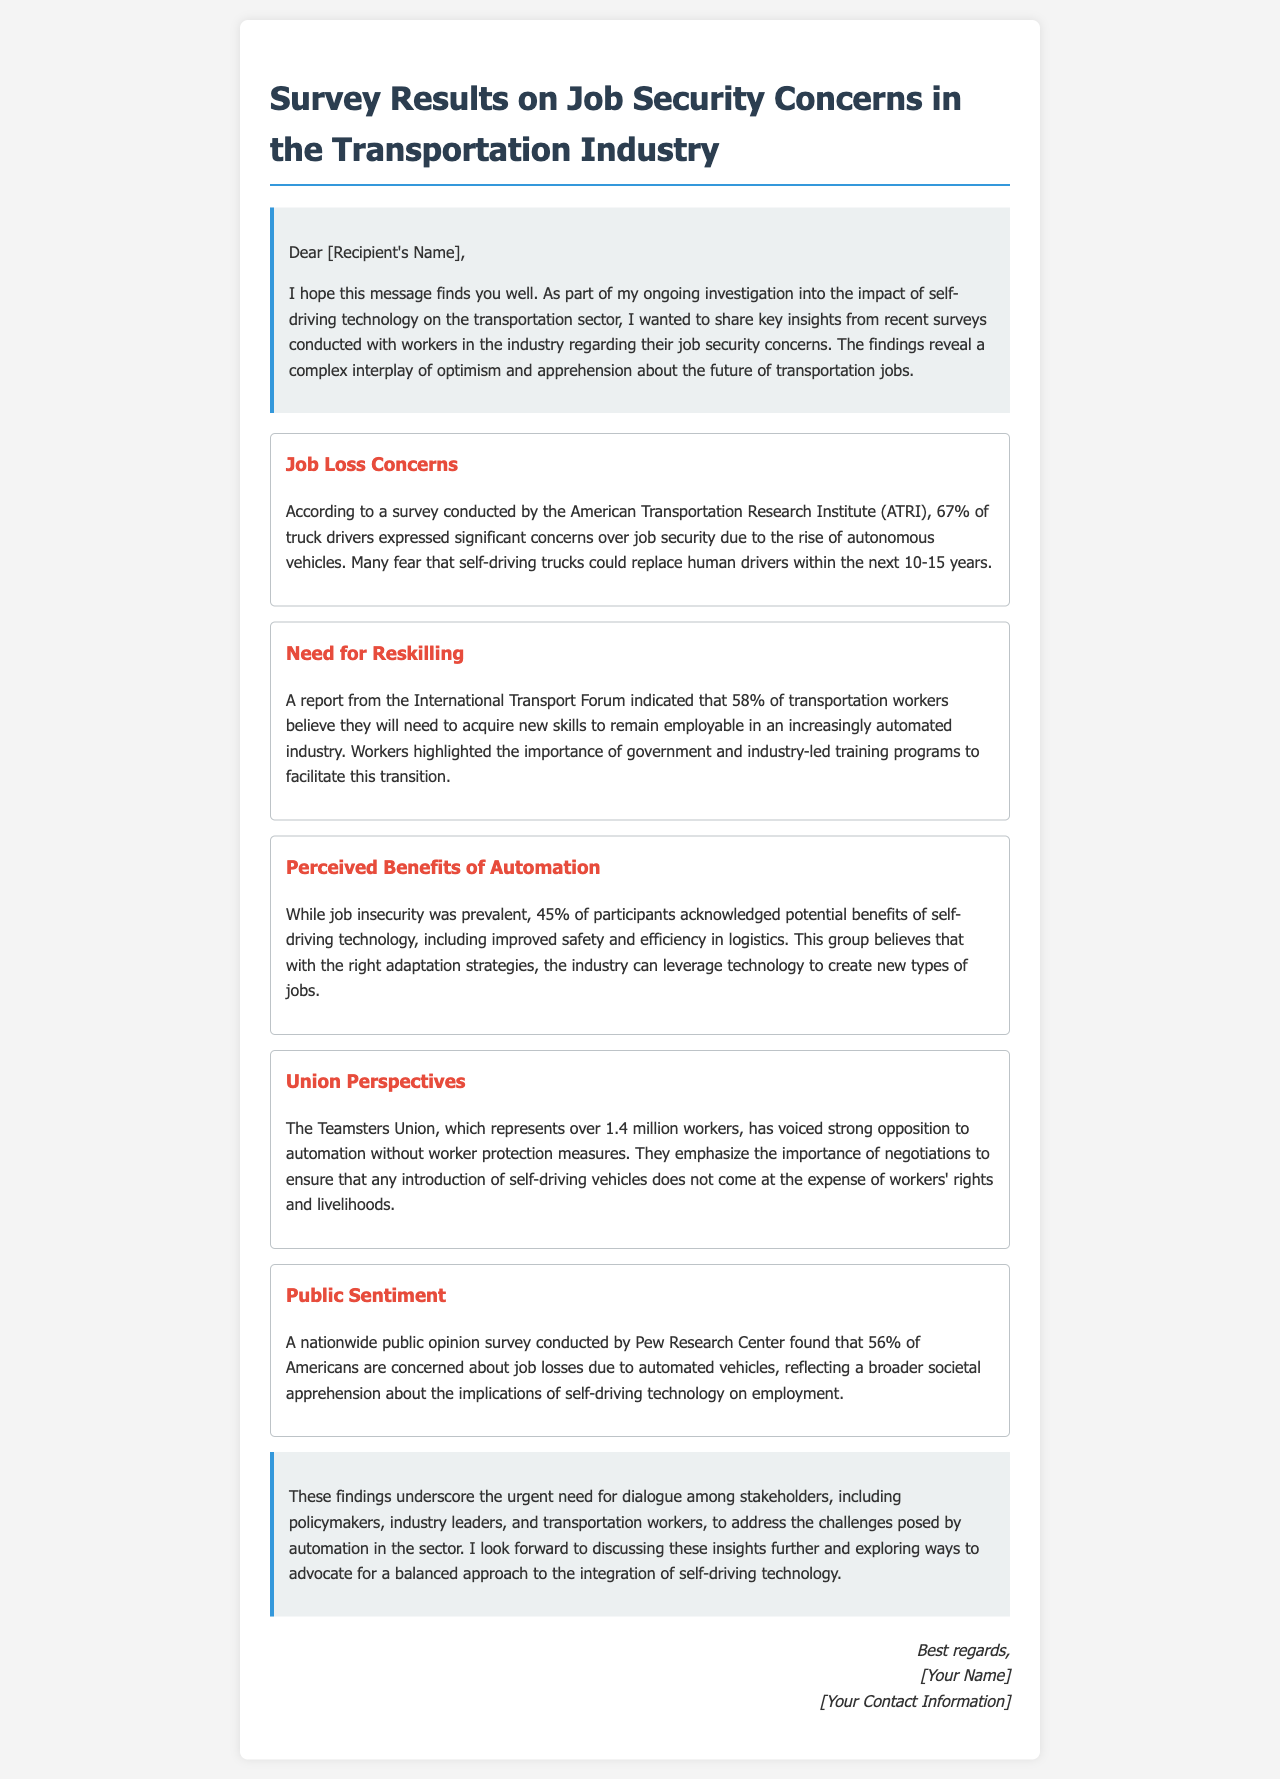What percentage of truck drivers are concerned about job security? The document states that 67% of truck drivers expressed significant concerns over job security due to the rise of autonomous vehicles.
Answer: 67% What is the reported percentage of transportation workers who believe they need to acquire new skills? According to the International Transport Forum, 58% of transportation workers believe they will need new skills to remain employable.
Answer: 58% What potential benefit of self-driving technology do 45% of participants acknowledge? The survey indicates that 45% acknowledge potential benefits of self-driving technology, including improved safety and efficiency in logistics.
Answer: Improved safety and efficiency Who represents over 1.4 million workers and opposes automation without protections? The Teamsters Union represents over 1.4 million workers and has voiced strong opposition to automation without worker protection measures.
Answer: Teamsters Union What percentage of Americans are concerned about job losses due to automated vehicles? The Pew Research Center found that 56% of Americans are concerned about job losses from automated vehicles.
Answer: 56% What overarching need is highlighted by the survey findings? The findings underscore the urgent need for dialogue among stakeholders, including policymakers, industry leaders, and transportation workers.
Answer: Dialogue among stakeholders How long do many truck drivers fear it will be until they are replaced by self-driving trucks? Many truck drivers fear that self-driving trucks could replace human drivers within the next 10-15 years.
Answer: 10-15 years What organization emphasized the importance of negotiations regarding worker rights? The Teamsters Union is the organization that emphasizes the need for negotiations to protect workers' rights amidst automation.
Answer: Teamsters Union What do workers highlight as crucial for adapting to automation in the industry? Workers highlight the importance of government and industry-led training programs to facilitate the transition amidst automation.
Answer: Training programs 